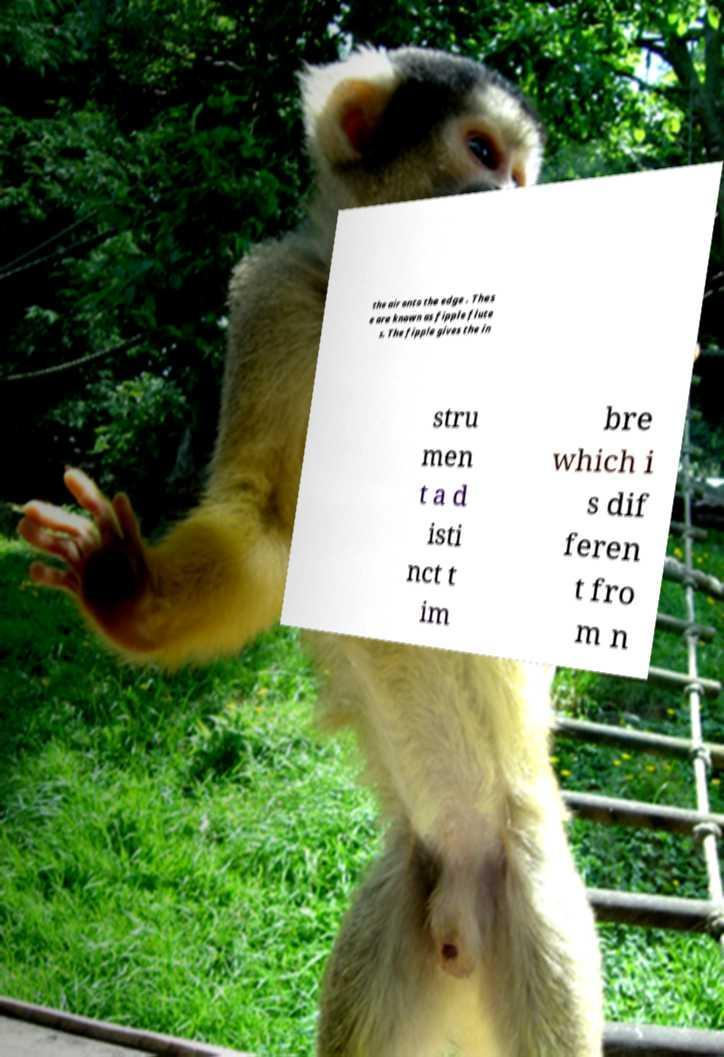Could you assist in decoding the text presented in this image and type it out clearly? the air onto the edge . Thes e are known as fipple flute s. The fipple gives the in stru men t a d isti nct t im bre which i s dif feren t fro m n 